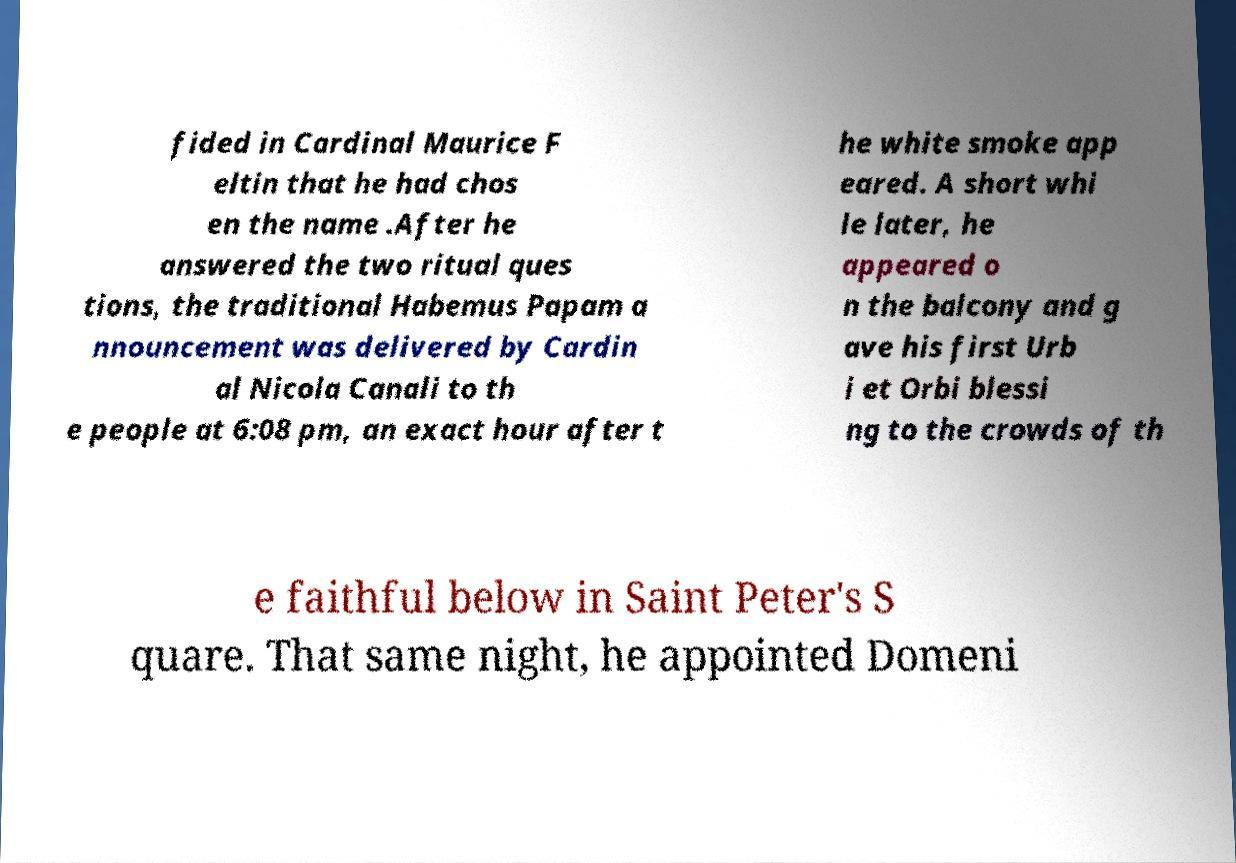Can you read and provide the text displayed in the image?This photo seems to have some interesting text. Can you extract and type it out for me? fided in Cardinal Maurice F eltin that he had chos en the name .After he answered the two ritual ques tions, the traditional Habemus Papam a nnouncement was delivered by Cardin al Nicola Canali to th e people at 6:08 pm, an exact hour after t he white smoke app eared. A short whi le later, he appeared o n the balcony and g ave his first Urb i et Orbi blessi ng to the crowds of th e faithful below in Saint Peter's S quare. That same night, he appointed Domeni 